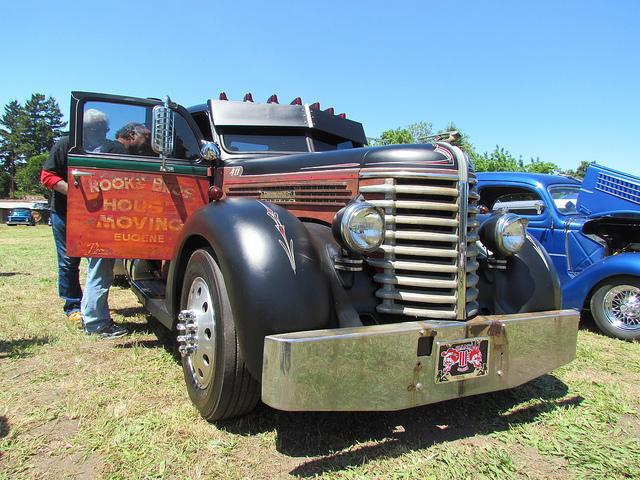These types of vehicles are commonly referred to as what? Please explain your reasoning. vintage. The truck is very old. older trucks are considered antiques when they are still in working condition. 